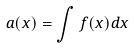Convert formula to latex. <formula><loc_0><loc_0><loc_500><loc_500>a ( x ) = \int f ( x ) d x</formula> 